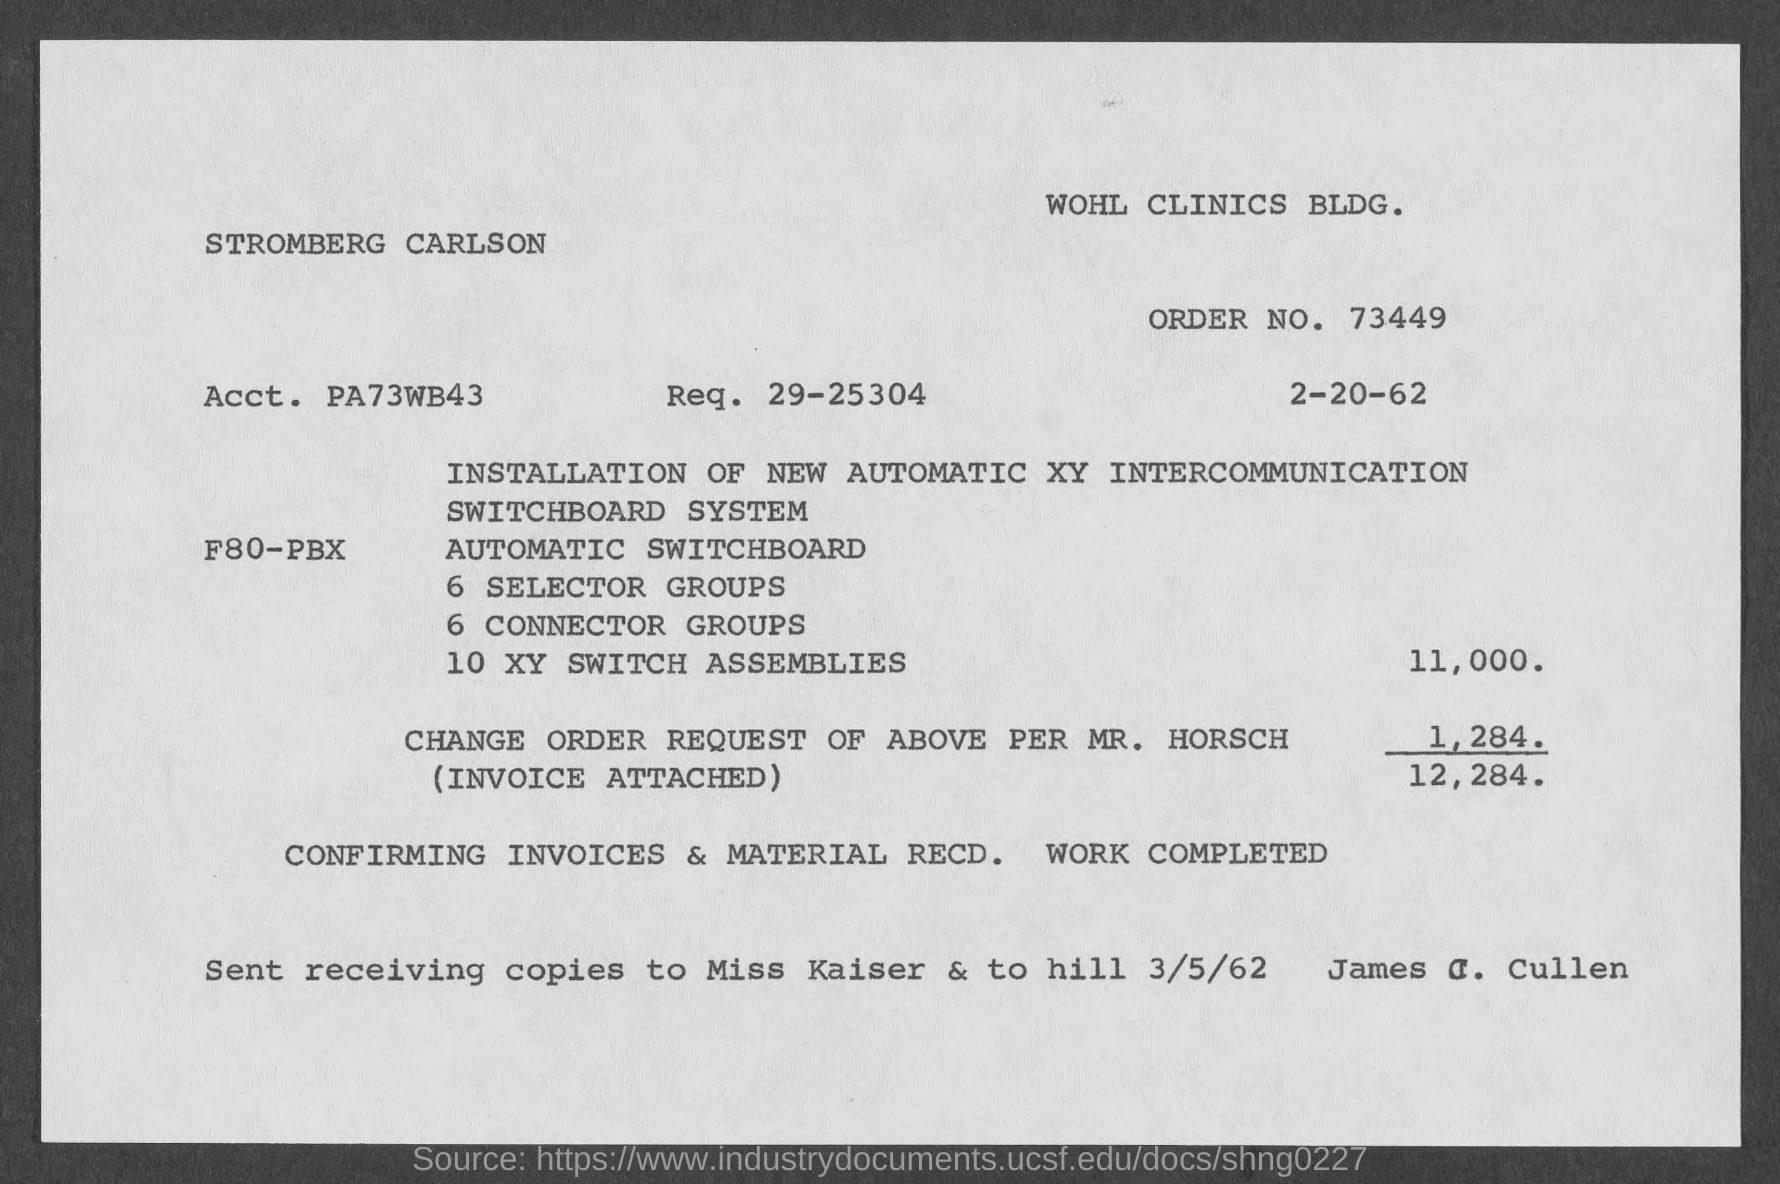Highlight a few significant elements in this photo. What is the order number? The invoice concerned the installation of a new automatic XY intercommunication switchboard system. The name of the building is WOHL CLINICS BLDG. The date on the invoice is February 20, 1962. 